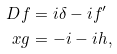<formula> <loc_0><loc_0><loc_500><loc_500>D f & = i \delta - i f ^ { \prime } \\ x g & = - i - i h ,</formula> 